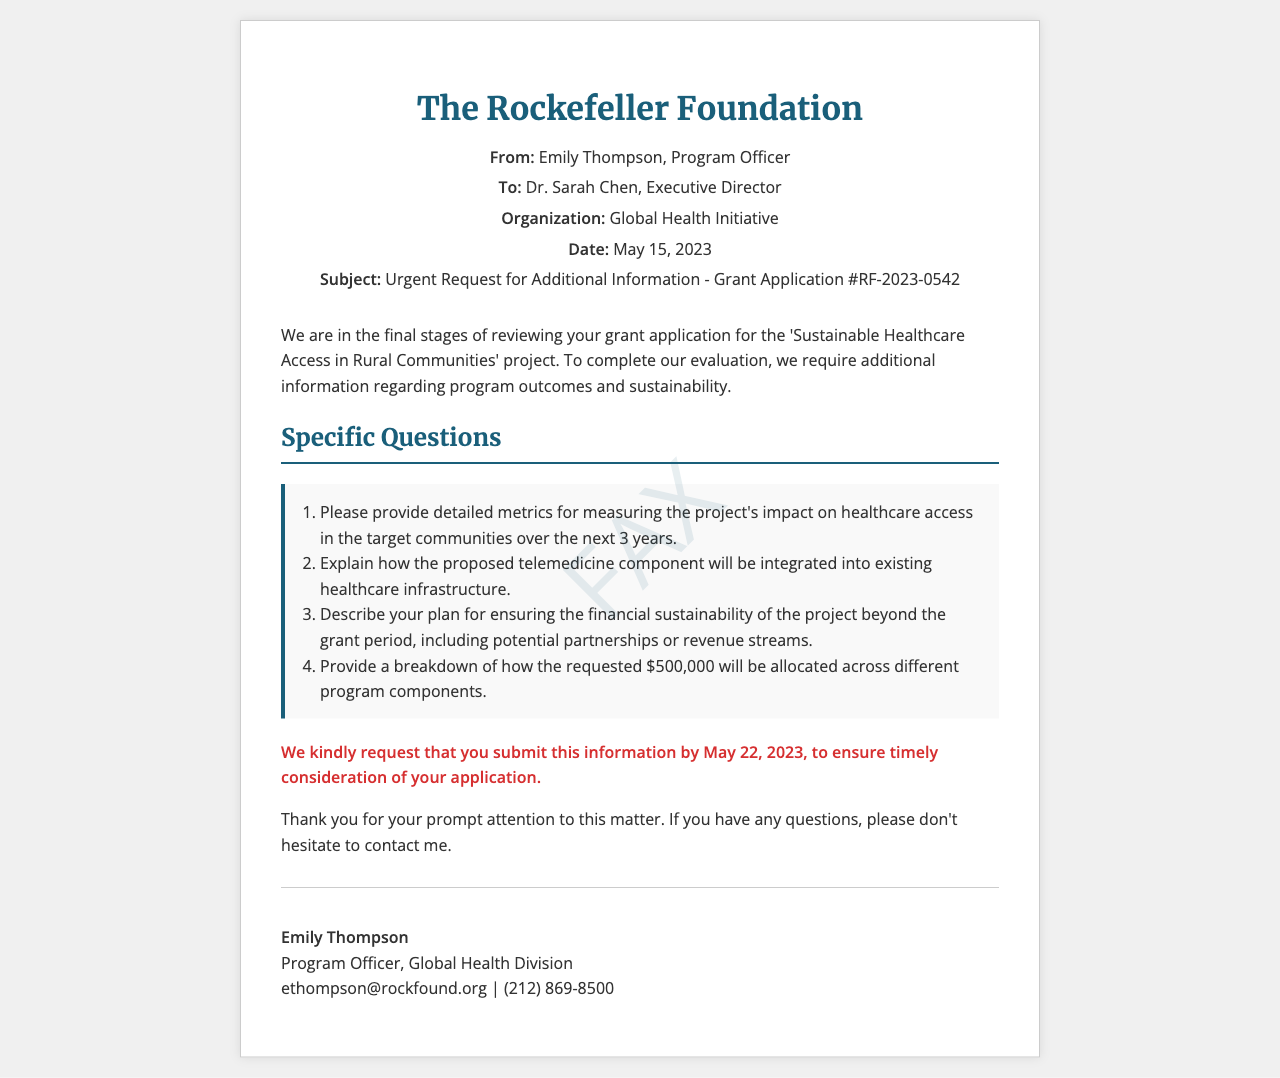What is the sender's name? The sender's name is mentioned in the document header as Emily Thompson.
Answer: Emily Thompson What is the subject of the fax? The subject line in the document specifies the matter being addressed, which is an urgent request for additional information on a grant application.
Answer: Urgent Request for Additional Information - Grant Application #RF-2023-0542 What is the requested submission deadline? The document clearly states the deadline for submitting the requested information, which is necessary for the application review process.
Answer: May 22, 2023 What is the total amount requested in the grant application? The total funding amount is outlined in the fax, particularly in the section discussing how the funds will be allocated.
Answer: $500,000 Which organization is applying for the grant? The grant application is attributed to a specific organization, which is named in the document.
Answer: Global Health Initiative What are the program outcomes that need to be detailed? The document outlines specific program outcomes related to healthcare access that the organization needs to elaborate on for their application review.
Answer: Healthcare access in the target communities What is the proposed integration method for telemedicine? The fax requests an explanation of how telemedicine will be introduced into existing healthcare infrastructures.
Answer: Integration into existing healthcare infrastructure Who should be contacted for questions? The signature section specifies the contact person for any inquiries regarding the fax content.
Answer: Emily Thompson What is the primary focus of the grant application? The main goal of the grant application is highlighted early in the document, referring to the type of project being proposed.
Answer: Sustainable Healthcare Access in Rural Communities 